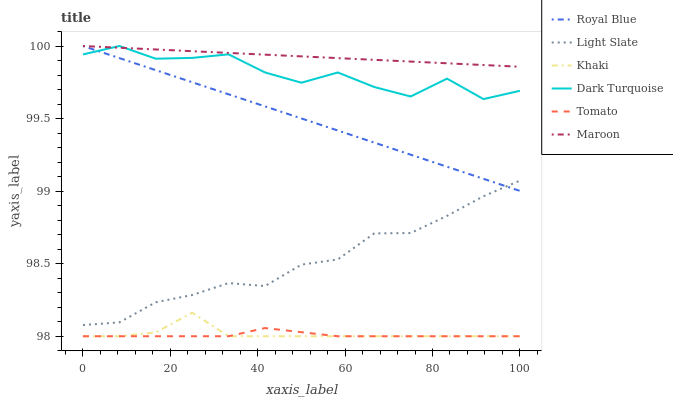Does Tomato have the minimum area under the curve?
Answer yes or no. Yes. Does Maroon have the maximum area under the curve?
Answer yes or no. Yes. Does Khaki have the minimum area under the curve?
Answer yes or no. No. Does Khaki have the maximum area under the curve?
Answer yes or no. No. Is Royal Blue the smoothest?
Answer yes or no. Yes. Is Dark Turquoise the roughest?
Answer yes or no. Yes. Is Khaki the smoothest?
Answer yes or no. No. Is Khaki the roughest?
Answer yes or no. No. Does Tomato have the lowest value?
Answer yes or no. Yes. Does Light Slate have the lowest value?
Answer yes or no. No. Does Royal Blue have the highest value?
Answer yes or no. Yes. Does Khaki have the highest value?
Answer yes or no. No. Is Tomato less than Royal Blue?
Answer yes or no. Yes. Is Maroon greater than Khaki?
Answer yes or no. Yes. Does Dark Turquoise intersect Royal Blue?
Answer yes or no. Yes. Is Dark Turquoise less than Royal Blue?
Answer yes or no. No. Is Dark Turquoise greater than Royal Blue?
Answer yes or no. No. Does Tomato intersect Royal Blue?
Answer yes or no. No. 